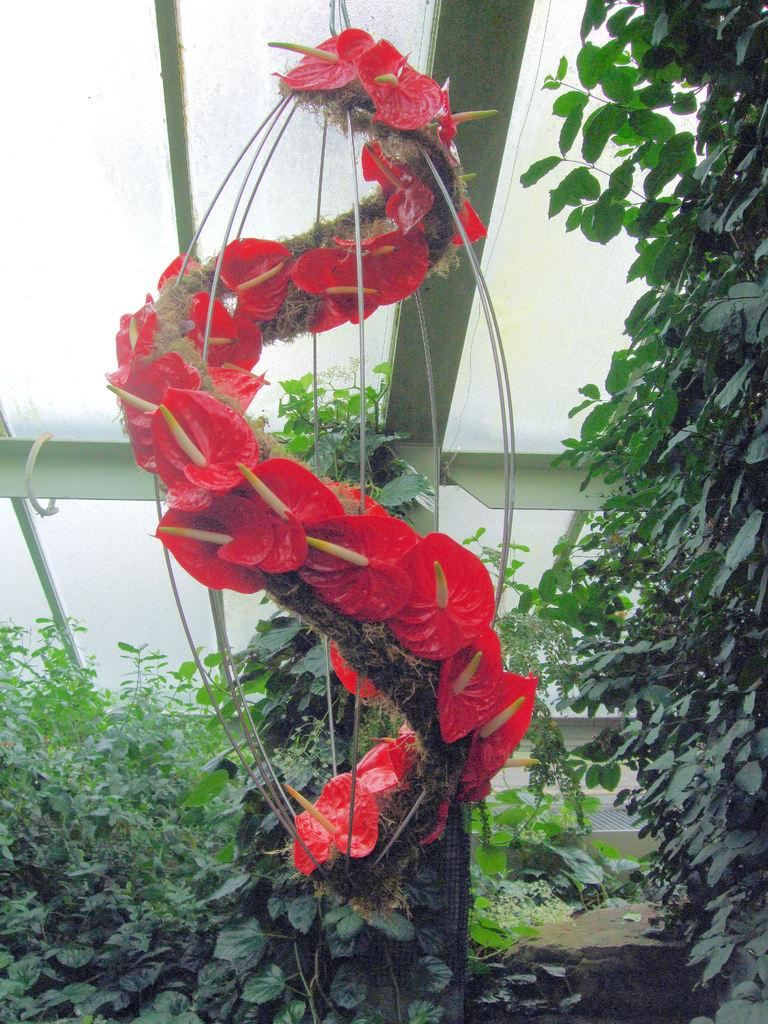What type of object is present in the image that has flowers? There is an object with flowers in the image. What other plant-related elements can be seen in the image? There are creepers in the image. What feature of the room is made of glass? There are glass panes on the ceiling. What structural elements are present on the ceiling? There are rods on the ceiling. How much does the brother weigh in the image? There is no brother present in the image, so it is not possible to determine their weight. 